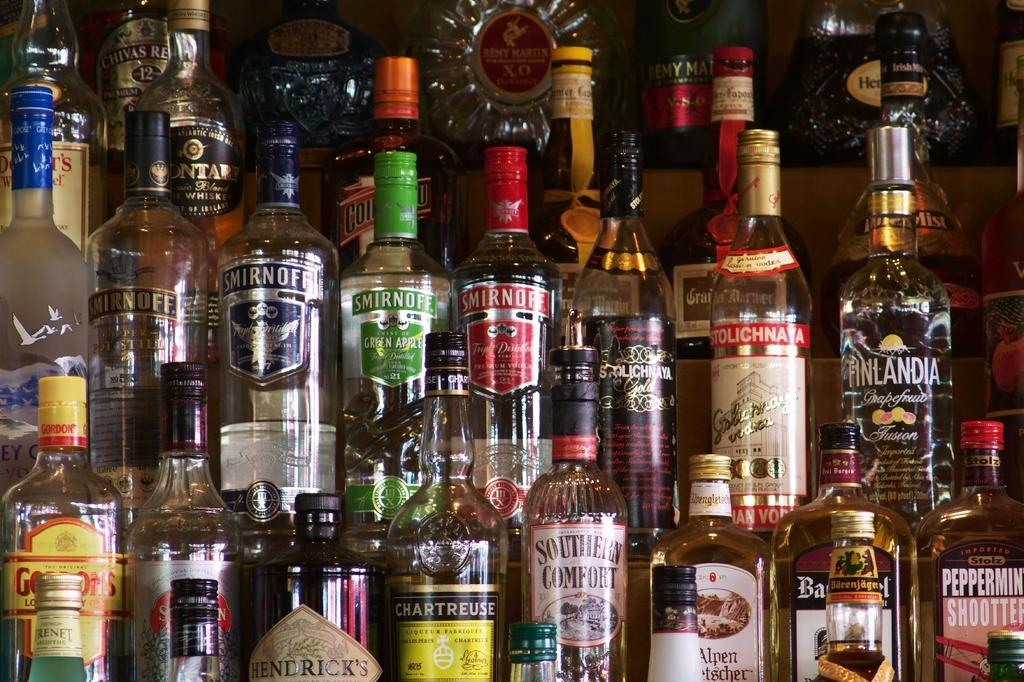<image>
Present a compact description of the photo's key features. A bunch of bottles of liquor, including many bottles of Smirnoff vodka. 